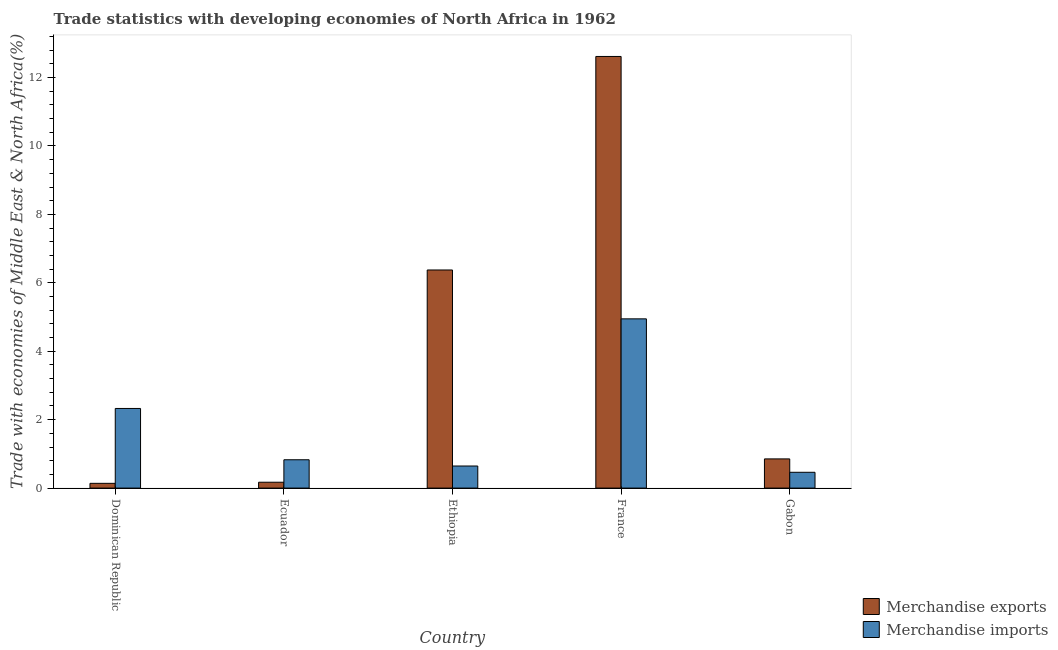How many different coloured bars are there?
Provide a short and direct response. 2. Are the number of bars per tick equal to the number of legend labels?
Make the answer very short. Yes. How many bars are there on the 3rd tick from the right?
Your answer should be very brief. 2. What is the label of the 3rd group of bars from the left?
Offer a terse response. Ethiopia. In how many cases, is the number of bars for a given country not equal to the number of legend labels?
Your response must be concise. 0. What is the merchandise exports in Ethiopia?
Provide a succinct answer. 6.38. Across all countries, what is the maximum merchandise exports?
Provide a succinct answer. 12.62. Across all countries, what is the minimum merchandise imports?
Make the answer very short. 0.46. In which country was the merchandise imports minimum?
Offer a very short reply. Gabon. What is the total merchandise exports in the graph?
Provide a short and direct response. 20.15. What is the difference between the merchandise imports in Dominican Republic and that in Gabon?
Make the answer very short. 1.87. What is the difference between the merchandise imports in Dominican Republic and the merchandise exports in France?
Offer a terse response. -10.29. What is the average merchandise exports per country?
Your response must be concise. 4.03. What is the difference between the merchandise exports and merchandise imports in Dominican Republic?
Offer a terse response. -2.19. In how many countries, is the merchandise exports greater than 12.4 %?
Provide a succinct answer. 1. What is the ratio of the merchandise imports in Dominican Republic to that in Gabon?
Offer a terse response. 5.04. What is the difference between the highest and the second highest merchandise imports?
Give a very brief answer. 2.62. What is the difference between the highest and the lowest merchandise exports?
Your answer should be very brief. 12.48. In how many countries, is the merchandise exports greater than the average merchandise exports taken over all countries?
Make the answer very short. 2. How many bars are there?
Your answer should be compact. 10. Are the values on the major ticks of Y-axis written in scientific E-notation?
Offer a terse response. No. Does the graph contain grids?
Give a very brief answer. No. Where does the legend appear in the graph?
Provide a succinct answer. Bottom right. How many legend labels are there?
Your response must be concise. 2. What is the title of the graph?
Offer a terse response. Trade statistics with developing economies of North Africa in 1962. What is the label or title of the X-axis?
Give a very brief answer. Country. What is the label or title of the Y-axis?
Make the answer very short. Trade with economies of Middle East & North Africa(%). What is the Trade with economies of Middle East & North Africa(%) of Merchandise exports in Dominican Republic?
Ensure brevity in your answer.  0.14. What is the Trade with economies of Middle East & North Africa(%) in Merchandise imports in Dominican Republic?
Your answer should be compact. 2.33. What is the Trade with economies of Middle East & North Africa(%) of Merchandise exports in Ecuador?
Keep it short and to the point. 0.17. What is the Trade with economies of Middle East & North Africa(%) in Merchandise imports in Ecuador?
Offer a very short reply. 0.83. What is the Trade with economies of Middle East & North Africa(%) of Merchandise exports in Ethiopia?
Keep it short and to the point. 6.38. What is the Trade with economies of Middle East & North Africa(%) of Merchandise imports in Ethiopia?
Your response must be concise. 0.65. What is the Trade with economies of Middle East & North Africa(%) in Merchandise exports in France?
Your answer should be very brief. 12.62. What is the Trade with economies of Middle East & North Africa(%) of Merchandise imports in France?
Make the answer very short. 4.95. What is the Trade with economies of Middle East & North Africa(%) of Merchandise exports in Gabon?
Provide a succinct answer. 0.85. What is the Trade with economies of Middle East & North Africa(%) in Merchandise imports in Gabon?
Your response must be concise. 0.46. Across all countries, what is the maximum Trade with economies of Middle East & North Africa(%) in Merchandise exports?
Your answer should be compact. 12.62. Across all countries, what is the maximum Trade with economies of Middle East & North Africa(%) of Merchandise imports?
Provide a short and direct response. 4.95. Across all countries, what is the minimum Trade with economies of Middle East & North Africa(%) in Merchandise exports?
Offer a terse response. 0.14. Across all countries, what is the minimum Trade with economies of Middle East & North Africa(%) in Merchandise imports?
Offer a very short reply. 0.46. What is the total Trade with economies of Middle East & North Africa(%) in Merchandise exports in the graph?
Your response must be concise. 20.15. What is the total Trade with economies of Middle East & North Africa(%) of Merchandise imports in the graph?
Make the answer very short. 9.21. What is the difference between the Trade with economies of Middle East & North Africa(%) in Merchandise exports in Dominican Republic and that in Ecuador?
Give a very brief answer. -0.03. What is the difference between the Trade with economies of Middle East & North Africa(%) of Merchandise imports in Dominican Republic and that in Ecuador?
Provide a succinct answer. 1.5. What is the difference between the Trade with economies of Middle East & North Africa(%) in Merchandise exports in Dominican Republic and that in Ethiopia?
Ensure brevity in your answer.  -6.24. What is the difference between the Trade with economies of Middle East & North Africa(%) in Merchandise imports in Dominican Republic and that in Ethiopia?
Keep it short and to the point. 1.68. What is the difference between the Trade with economies of Middle East & North Africa(%) of Merchandise exports in Dominican Republic and that in France?
Provide a short and direct response. -12.48. What is the difference between the Trade with economies of Middle East & North Africa(%) in Merchandise imports in Dominican Republic and that in France?
Your answer should be very brief. -2.62. What is the difference between the Trade with economies of Middle East & North Africa(%) in Merchandise exports in Dominican Republic and that in Gabon?
Keep it short and to the point. -0.71. What is the difference between the Trade with economies of Middle East & North Africa(%) in Merchandise imports in Dominican Republic and that in Gabon?
Keep it short and to the point. 1.87. What is the difference between the Trade with economies of Middle East & North Africa(%) in Merchandise exports in Ecuador and that in Ethiopia?
Your response must be concise. -6.2. What is the difference between the Trade with economies of Middle East & North Africa(%) of Merchandise imports in Ecuador and that in Ethiopia?
Your response must be concise. 0.18. What is the difference between the Trade with economies of Middle East & North Africa(%) of Merchandise exports in Ecuador and that in France?
Offer a very short reply. -12.44. What is the difference between the Trade with economies of Middle East & North Africa(%) in Merchandise imports in Ecuador and that in France?
Ensure brevity in your answer.  -4.12. What is the difference between the Trade with economies of Middle East & North Africa(%) of Merchandise exports in Ecuador and that in Gabon?
Make the answer very short. -0.68. What is the difference between the Trade with economies of Middle East & North Africa(%) in Merchandise imports in Ecuador and that in Gabon?
Provide a succinct answer. 0.37. What is the difference between the Trade with economies of Middle East & North Africa(%) of Merchandise exports in Ethiopia and that in France?
Your response must be concise. -6.24. What is the difference between the Trade with economies of Middle East & North Africa(%) in Merchandise imports in Ethiopia and that in France?
Your answer should be very brief. -4.3. What is the difference between the Trade with economies of Middle East & North Africa(%) in Merchandise exports in Ethiopia and that in Gabon?
Your answer should be compact. 5.52. What is the difference between the Trade with economies of Middle East & North Africa(%) of Merchandise imports in Ethiopia and that in Gabon?
Offer a very short reply. 0.18. What is the difference between the Trade with economies of Middle East & North Africa(%) in Merchandise exports in France and that in Gabon?
Keep it short and to the point. 11.76. What is the difference between the Trade with economies of Middle East & North Africa(%) in Merchandise imports in France and that in Gabon?
Your response must be concise. 4.48. What is the difference between the Trade with economies of Middle East & North Africa(%) in Merchandise exports in Dominican Republic and the Trade with economies of Middle East & North Africa(%) in Merchandise imports in Ecuador?
Offer a terse response. -0.69. What is the difference between the Trade with economies of Middle East & North Africa(%) of Merchandise exports in Dominican Republic and the Trade with economies of Middle East & North Africa(%) of Merchandise imports in Ethiopia?
Give a very brief answer. -0.51. What is the difference between the Trade with economies of Middle East & North Africa(%) in Merchandise exports in Dominican Republic and the Trade with economies of Middle East & North Africa(%) in Merchandise imports in France?
Ensure brevity in your answer.  -4.81. What is the difference between the Trade with economies of Middle East & North Africa(%) in Merchandise exports in Dominican Republic and the Trade with economies of Middle East & North Africa(%) in Merchandise imports in Gabon?
Provide a succinct answer. -0.32. What is the difference between the Trade with economies of Middle East & North Africa(%) in Merchandise exports in Ecuador and the Trade with economies of Middle East & North Africa(%) in Merchandise imports in Ethiopia?
Offer a terse response. -0.47. What is the difference between the Trade with economies of Middle East & North Africa(%) in Merchandise exports in Ecuador and the Trade with economies of Middle East & North Africa(%) in Merchandise imports in France?
Offer a very short reply. -4.78. What is the difference between the Trade with economies of Middle East & North Africa(%) in Merchandise exports in Ecuador and the Trade with economies of Middle East & North Africa(%) in Merchandise imports in Gabon?
Your response must be concise. -0.29. What is the difference between the Trade with economies of Middle East & North Africa(%) in Merchandise exports in Ethiopia and the Trade with economies of Middle East & North Africa(%) in Merchandise imports in France?
Your answer should be very brief. 1.43. What is the difference between the Trade with economies of Middle East & North Africa(%) in Merchandise exports in Ethiopia and the Trade with economies of Middle East & North Africa(%) in Merchandise imports in Gabon?
Offer a very short reply. 5.91. What is the difference between the Trade with economies of Middle East & North Africa(%) in Merchandise exports in France and the Trade with economies of Middle East & North Africa(%) in Merchandise imports in Gabon?
Your answer should be compact. 12.15. What is the average Trade with economies of Middle East & North Africa(%) in Merchandise exports per country?
Provide a short and direct response. 4.03. What is the average Trade with economies of Middle East & North Africa(%) in Merchandise imports per country?
Offer a terse response. 1.84. What is the difference between the Trade with economies of Middle East & North Africa(%) in Merchandise exports and Trade with economies of Middle East & North Africa(%) in Merchandise imports in Dominican Republic?
Give a very brief answer. -2.19. What is the difference between the Trade with economies of Middle East & North Africa(%) of Merchandise exports and Trade with economies of Middle East & North Africa(%) of Merchandise imports in Ecuador?
Offer a very short reply. -0.66. What is the difference between the Trade with economies of Middle East & North Africa(%) in Merchandise exports and Trade with economies of Middle East & North Africa(%) in Merchandise imports in Ethiopia?
Give a very brief answer. 5.73. What is the difference between the Trade with economies of Middle East & North Africa(%) of Merchandise exports and Trade with economies of Middle East & North Africa(%) of Merchandise imports in France?
Ensure brevity in your answer.  7.67. What is the difference between the Trade with economies of Middle East & North Africa(%) of Merchandise exports and Trade with economies of Middle East & North Africa(%) of Merchandise imports in Gabon?
Offer a terse response. 0.39. What is the ratio of the Trade with economies of Middle East & North Africa(%) in Merchandise exports in Dominican Republic to that in Ecuador?
Provide a succinct answer. 0.81. What is the ratio of the Trade with economies of Middle East & North Africa(%) of Merchandise imports in Dominican Republic to that in Ecuador?
Your answer should be compact. 2.81. What is the ratio of the Trade with economies of Middle East & North Africa(%) of Merchandise exports in Dominican Republic to that in Ethiopia?
Offer a very short reply. 0.02. What is the ratio of the Trade with economies of Middle East & North Africa(%) in Merchandise imports in Dominican Republic to that in Ethiopia?
Ensure brevity in your answer.  3.61. What is the ratio of the Trade with economies of Middle East & North Africa(%) in Merchandise exports in Dominican Republic to that in France?
Your response must be concise. 0.01. What is the ratio of the Trade with economies of Middle East & North Africa(%) in Merchandise imports in Dominican Republic to that in France?
Ensure brevity in your answer.  0.47. What is the ratio of the Trade with economies of Middle East & North Africa(%) of Merchandise exports in Dominican Republic to that in Gabon?
Offer a terse response. 0.16. What is the ratio of the Trade with economies of Middle East & North Africa(%) in Merchandise imports in Dominican Republic to that in Gabon?
Keep it short and to the point. 5.04. What is the ratio of the Trade with economies of Middle East & North Africa(%) in Merchandise exports in Ecuador to that in Ethiopia?
Offer a terse response. 0.03. What is the ratio of the Trade with economies of Middle East & North Africa(%) of Merchandise imports in Ecuador to that in Ethiopia?
Your response must be concise. 1.28. What is the ratio of the Trade with economies of Middle East & North Africa(%) in Merchandise exports in Ecuador to that in France?
Offer a very short reply. 0.01. What is the ratio of the Trade with economies of Middle East & North Africa(%) in Merchandise imports in Ecuador to that in France?
Make the answer very short. 0.17. What is the ratio of the Trade with economies of Middle East & North Africa(%) in Merchandise exports in Ecuador to that in Gabon?
Provide a short and direct response. 0.2. What is the ratio of the Trade with economies of Middle East & North Africa(%) of Merchandise imports in Ecuador to that in Gabon?
Provide a short and direct response. 1.79. What is the ratio of the Trade with economies of Middle East & North Africa(%) in Merchandise exports in Ethiopia to that in France?
Your response must be concise. 0.51. What is the ratio of the Trade with economies of Middle East & North Africa(%) of Merchandise imports in Ethiopia to that in France?
Keep it short and to the point. 0.13. What is the ratio of the Trade with economies of Middle East & North Africa(%) of Merchandise exports in Ethiopia to that in Gabon?
Ensure brevity in your answer.  7.47. What is the ratio of the Trade with economies of Middle East & North Africa(%) of Merchandise imports in Ethiopia to that in Gabon?
Give a very brief answer. 1.4. What is the ratio of the Trade with economies of Middle East & North Africa(%) of Merchandise exports in France to that in Gabon?
Offer a very short reply. 14.79. What is the ratio of the Trade with economies of Middle East & North Africa(%) in Merchandise imports in France to that in Gabon?
Offer a terse response. 10.71. What is the difference between the highest and the second highest Trade with economies of Middle East & North Africa(%) of Merchandise exports?
Keep it short and to the point. 6.24. What is the difference between the highest and the second highest Trade with economies of Middle East & North Africa(%) in Merchandise imports?
Give a very brief answer. 2.62. What is the difference between the highest and the lowest Trade with economies of Middle East & North Africa(%) in Merchandise exports?
Offer a very short reply. 12.48. What is the difference between the highest and the lowest Trade with economies of Middle East & North Africa(%) in Merchandise imports?
Ensure brevity in your answer.  4.48. 